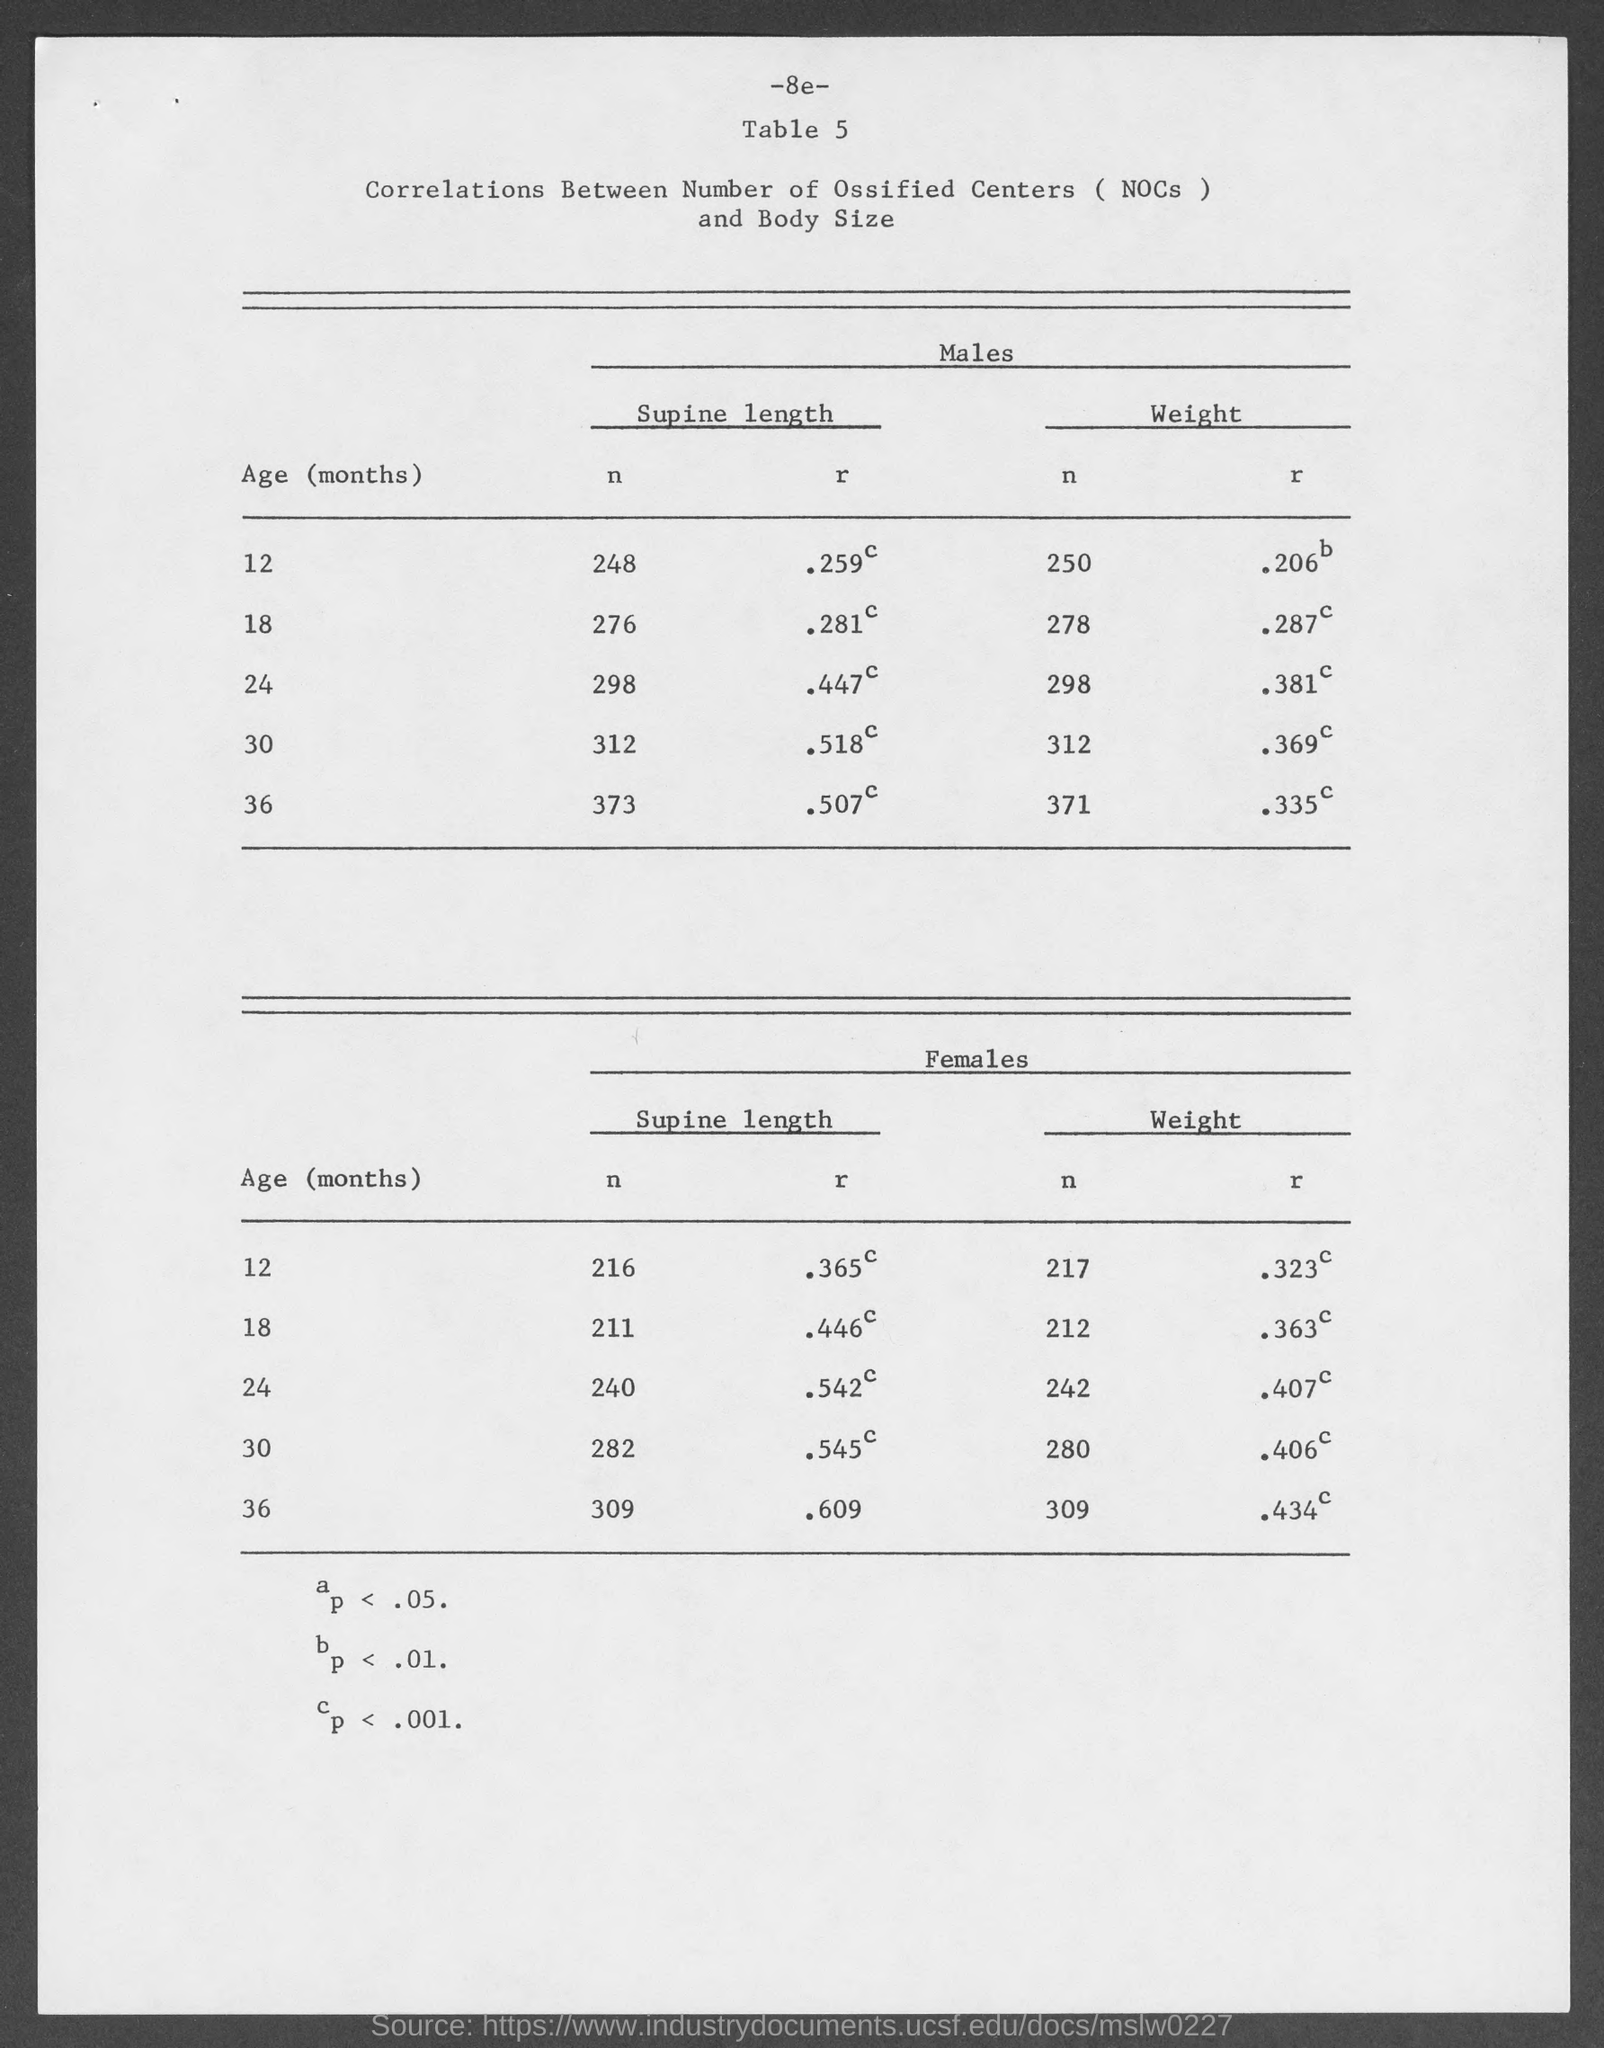What is the supine length of n for males at the age of 12 months ?
Make the answer very short. 248. What is the supine length of n for males at the age of 18 months ?
Offer a very short reply. 276. What is the supine length of n for males at the age of 24 months ?
Provide a succinct answer. 298. What is the supine length of n for males at the age of 30 months ?
Provide a succinct answer. 312. What is the supine length of n for males at the age of 36 months ?
Offer a terse response. 373. What is the weight of n for males at the age of 12 months ?
Provide a short and direct response. 250. What is the weight of n for males at the age of 18 months ?
Offer a terse response. 278. What is the weight of n for males at the age of 24 months ?
Keep it short and to the point. 298. What is the weight of n for males at the age of 30 months ?
Make the answer very short. 312. 